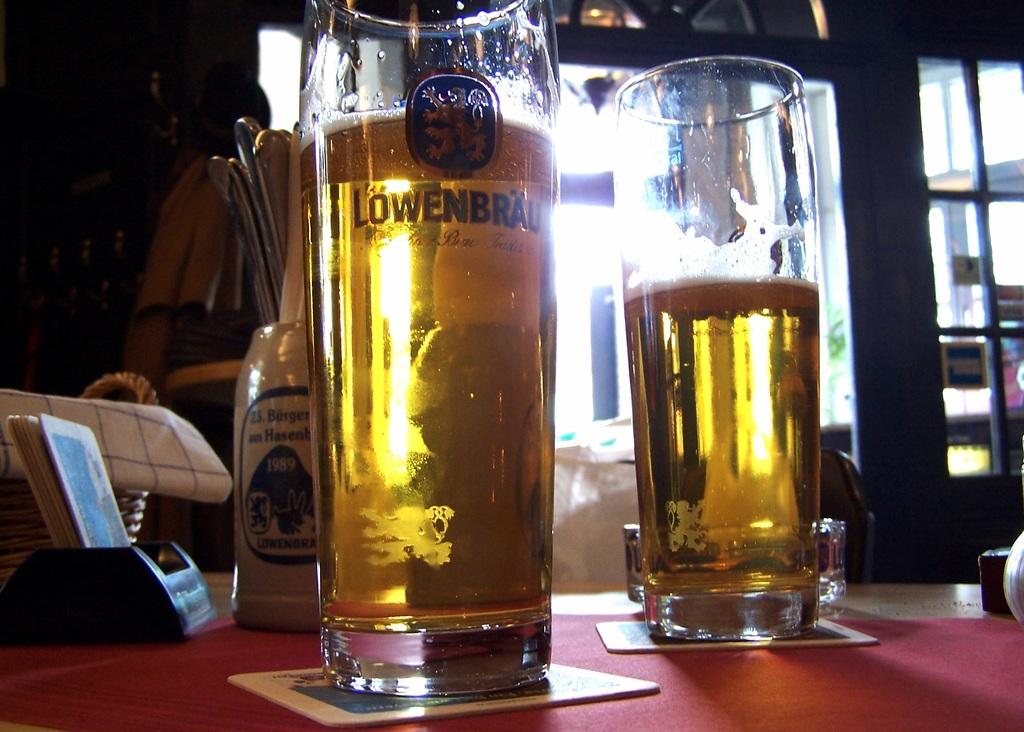What type of beer is this?
Make the answer very short. Lowenbrau. 